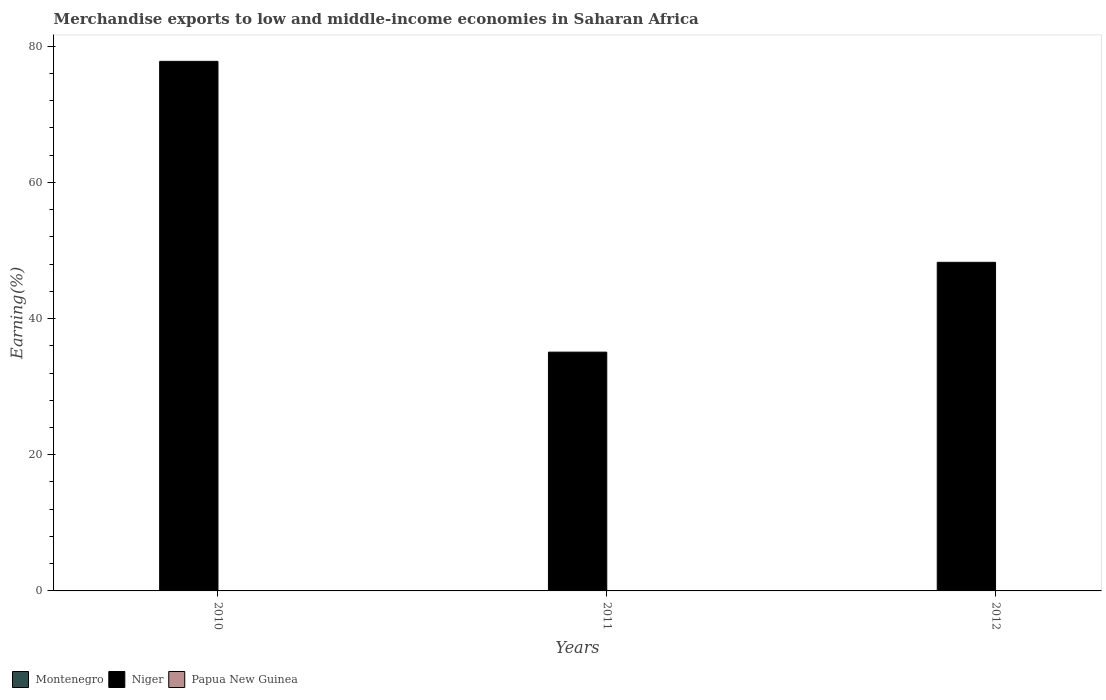Are the number of bars per tick equal to the number of legend labels?
Your answer should be very brief. Yes. Are the number of bars on each tick of the X-axis equal?
Your response must be concise. Yes. How many bars are there on the 2nd tick from the left?
Offer a terse response. 3. How many bars are there on the 2nd tick from the right?
Provide a succinct answer. 3. What is the label of the 1st group of bars from the left?
Ensure brevity in your answer.  2010. What is the percentage of amount earned from merchandise exports in Niger in 2012?
Provide a succinct answer. 48.26. Across all years, what is the maximum percentage of amount earned from merchandise exports in Niger?
Your answer should be compact. 77.78. Across all years, what is the minimum percentage of amount earned from merchandise exports in Niger?
Offer a very short reply. 35.07. In which year was the percentage of amount earned from merchandise exports in Montenegro maximum?
Your response must be concise. 2010. What is the total percentage of amount earned from merchandise exports in Papua New Guinea in the graph?
Provide a short and direct response. 0.02. What is the difference between the percentage of amount earned from merchandise exports in Niger in 2010 and that in 2012?
Your answer should be compact. 29.52. What is the difference between the percentage of amount earned from merchandise exports in Montenegro in 2011 and the percentage of amount earned from merchandise exports in Papua New Guinea in 2010?
Provide a short and direct response. 0. What is the average percentage of amount earned from merchandise exports in Montenegro per year?
Offer a very short reply. 0.02. In the year 2011, what is the difference between the percentage of amount earned from merchandise exports in Montenegro and percentage of amount earned from merchandise exports in Papua New Guinea?
Provide a succinct answer. 0.01. In how many years, is the percentage of amount earned from merchandise exports in Niger greater than 72 %?
Offer a very short reply. 1. What is the ratio of the percentage of amount earned from merchandise exports in Niger in 2010 to that in 2012?
Offer a very short reply. 1.61. Is the difference between the percentage of amount earned from merchandise exports in Montenegro in 2010 and 2012 greater than the difference between the percentage of amount earned from merchandise exports in Papua New Guinea in 2010 and 2012?
Offer a very short reply. Yes. What is the difference between the highest and the second highest percentage of amount earned from merchandise exports in Niger?
Ensure brevity in your answer.  29.52. What is the difference between the highest and the lowest percentage of amount earned from merchandise exports in Papua New Guinea?
Ensure brevity in your answer.  0.01. In how many years, is the percentage of amount earned from merchandise exports in Montenegro greater than the average percentage of amount earned from merchandise exports in Montenegro taken over all years?
Make the answer very short. 1. What does the 1st bar from the left in 2012 represents?
Provide a succinct answer. Montenegro. What does the 3rd bar from the right in 2011 represents?
Offer a terse response. Montenegro. How many bars are there?
Offer a very short reply. 9. Are all the bars in the graph horizontal?
Make the answer very short. No. Where does the legend appear in the graph?
Your answer should be compact. Bottom left. How are the legend labels stacked?
Your answer should be very brief. Horizontal. What is the title of the graph?
Provide a short and direct response. Merchandise exports to low and middle-income economies in Saharan Africa. What is the label or title of the X-axis?
Ensure brevity in your answer.  Years. What is the label or title of the Y-axis?
Your answer should be compact. Earning(%). What is the Earning(%) in Montenegro in 2010?
Provide a short and direct response. 0.03. What is the Earning(%) of Niger in 2010?
Offer a very short reply. 77.78. What is the Earning(%) of Papua New Guinea in 2010?
Give a very brief answer. 0.01. What is the Earning(%) of Montenegro in 2011?
Make the answer very short. 0.01. What is the Earning(%) in Niger in 2011?
Your answer should be very brief. 35.07. What is the Earning(%) of Papua New Guinea in 2011?
Make the answer very short. 0. What is the Earning(%) of Montenegro in 2012?
Your response must be concise. 0.01. What is the Earning(%) of Niger in 2012?
Make the answer very short. 48.26. What is the Earning(%) in Papua New Guinea in 2012?
Ensure brevity in your answer.  0. Across all years, what is the maximum Earning(%) in Montenegro?
Keep it short and to the point. 0.03. Across all years, what is the maximum Earning(%) in Niger?
Your answer should be compact. 77.78. Across all years, what is the maximum Earning(%) of Papua New Guinea?
Ensure brevity in your answer.  0.01. Across all years, what is the minimum Earning(%) in Montenegro?
Your answer should be very brief. 0.01. Across all years, what is the minimum Earning(%) in Niger?
Your response must be concise. 35.07. Across all years, what is the minimum Earning(%) of Papua New Guinea?
Ensure brevity in your answer.  0. What is the total Earning(%) of Montenegro in the graph?
Keep it short and to the point. 0.05. What is the total Earning(%) in Niger in the graph?
Give a very brief answer. 161.1. What is the total Earning(%) of Papua New Guinea in the graph?
Your answer should be very brief. 0.02. What is the difference between the Earning(%) in Montenegro in 2010 and that in 2011?
Provide a short and direct response. 0.02. What is the difference between the Earning(%) of Niger in 2010 and that in 2011?
Your answer should be compact. 42.71. What is the difference between the Earning(%) of Papua New Guinea in 2010 and that in 2011?
Keep it short and to the point. 0.01. What is the difference between the Earning(%) in Montenegro in 2010 and that in 2012?
Provide a short and direct response. 0.01. What is the difference between the Earning(%) in Niger in 2010 and that in 2012?
Your answer should be compact. 29.52. What is the difference between the Earning(%) in Papua New Guinea in 2010 and that in 2012?
Make the answer very short. 0.01. What is the difference between the Earning(%) of Montenegro in 2011 and that in 2012?
Give a very brief answer. -0. What is the difference between the Earning(%) in Niger in 2011 and that in 2012?
Offer a very short reply. -13.19. What is the difference between the Earning(%) of Papua New Guinea in 2011 and that in 2012?
Keep it short and to the point. 0. What is the difference between the Earning(%) of Montenegro in 2010 and the Earning(%) of Niger in 2011?
Provide a short and direct response. -35.04. What is the difference between the Earning(%) of Montenegro in 2010 and the Earning(%) of Papua New Guinea in 2011?
Ensure brevity in your answer.  0.02. What is the difference between the Earning(%) in Niger in 2010 and the Earning(%) in Papua New Guinea in 2011?
Your response must be concise. 77.77. What is the difference between the Earning(%) in Montenegro in 2010 and the Earning(%) in Niger in 2012?
Provide a succinct answer. -48.23. What is the difference between the Earning(%) in Montenegro in 2010 and the Earning(%) in Papua New Guinea in 2012?
Your answer should be very brief. 0.03. What is the difference between the Earning(%) of Niger in 2010 and the Earning(%) of Papua New Guinea in 2012?
Ensure brevity in your answer.  77.77. What is the difference between the Earning(%) in Montenegro in 2011 and the Earning(%) in Niger in 2012?
Ensure brevity in your answer.  -48.25. What is the difference between the Earning(%) in Montenegro in 2011 and the Earning(%) in Papua New Guinea in 2012?
Keep it short and to the point. 0.01. What is the difference between the Earning(%) in Niger in 2011 and the Earning(%) in Papua New Guinea in 2012?
Provide a short and direct response. 35.07. What is the average Earning(%) in Montenegro per year?
Your response must be concise. 0.02. What is the average Earning(%) of Niger per year?
Your response must be concise. 53.7. What is the average Earning(%) of Papua New Guinea per year?
Ensure brevity in your answer.  0.01. In the year 2010, what is the difference between the Earning(%) of Montenegro and Earning(%) of Niger?
Your answer should be very brief. -77.75. In the year 2010, what is the difference between the Earning(%) of Montenegro and Earning(%) of Papua New Guinea?
Give a very brief answer. 0.02. In the year 2010, what is the difference between the Earning(%) in Niger and Earning(%) in Papua New Guinea?
Your response must be concise. 77.77. In the year 2011, what is the difference between the Earning(%) of Montenegro and Earning(%) of Niger?
Offer a very short reply. -35.06. In the year 2011, what is the difference between the Earning(%) in Montenegro and Earning(%) in Papua New Guinea?
Provide a succinct answer. 0.01. In the year 2011, what is the difference between the Earning(%) in Niger and Earning(%) in Papua New Guinea?
Ensure brevity in your answer.  35.06. In the year 2012, what is the difference between the Earning(%) in Montenegro and Earning(%) in Niger?
Provide a succinct answer. -48.25. In the year 2012, what is the difference between the Earning(%) of Montenegro and Earning(%) of Papua New Guinea?
Make the answer very short. 0.01. In the year 2012, what is the difference between the Earning(%) in Niger and Earning(%) in Papua New Guinea?
Provide a succinct answer. 48.26. What is the ratio of the Earning(%) of Montenegro in 2010 to that in 2011?
Provide a succinct answer. 2.51. What is the ratio of the Earning(%) in Niger in 2010 to that in 2011?
Ensure brevity in your answer.  2.22. What is the ratio of the Earning(%) of Papua New Guinea in 2010 to that in 2011?
Keep it short and to the point. 2.54. What is the ratio of the Earning(%) of Montenegro in 2010 to that in 2012?
Provide a succinct answer. 1.94. What is the ratio of the Earning(%) in Niger in 2010 to that in 2012?
Offer a terse response. 1.61. What is the ratio of the Earning(%) in Papua New Guinea in 2010 to that in 2012?
Provide a succinct answer. 3.16. What is the ratio of the Earning(%) in Montenegro in 2011 to that in 2012?
Offer a very short reply. 0.77. What is the ratio of the Earning(%) of Niger in 2011 to that in 2012?
Keep it short and to the point. 0.73. What is the ratio of the Earning(%) in Papua New Guinea in 2011 to that in 2012?
Offer a terse response. 1.24. What is the difference between the highest and the second highest Earning(%) in Montenegro?
Offer a very short reply. 0.01. What is the difference between the highest and the second highest Earning(%) of Niger?
Provide a succinct answer. 29.52. What is the difference between the highest and the second highest Earning(%) in Papua New Guinea?
Make the answer very short. 0.01. What is the difference between the highest and the lowest Earning(%) in Montenegro?
Your response must be concise. 0.02. What is the difference between the highest and the lowest Earning(%) in Niger?
Your response must be concise. 42.71. What is the difference between the highest and the lowest Earning(%) of Papua New Guinea?
Provide a succinct answer. 0.01. 